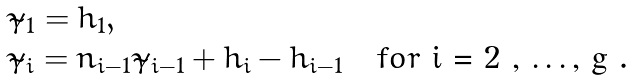<formula> <loc_0><loc_0><loc_500><loc_500>\begin{array} { l l l } \tilde { \gamma } _ { 1 } = h _ { 1 } , & & \\ \tilde { \gamma } _ { i } = n _ { i - 1 } \tilde { \gamma } _ { i - 1 } + h _ { i } - h _ { i - 1 } & & f o r $ i = 2 , \dots , g $ . \end{array}</formula> 